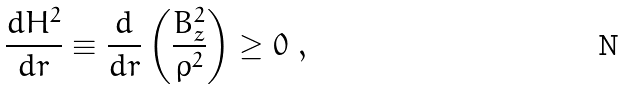Convert formula to latex. <formula><loc_0><loc_0><loc_500><loc_500>\frac { d H ^ { 2 } } { d r } \equiv \frac { d } { d r } \left ( \frac { B _ { z } ^ { 2 } } { \rho ^ { 2 } } \right ) \geq 0 \ ,</formula> 